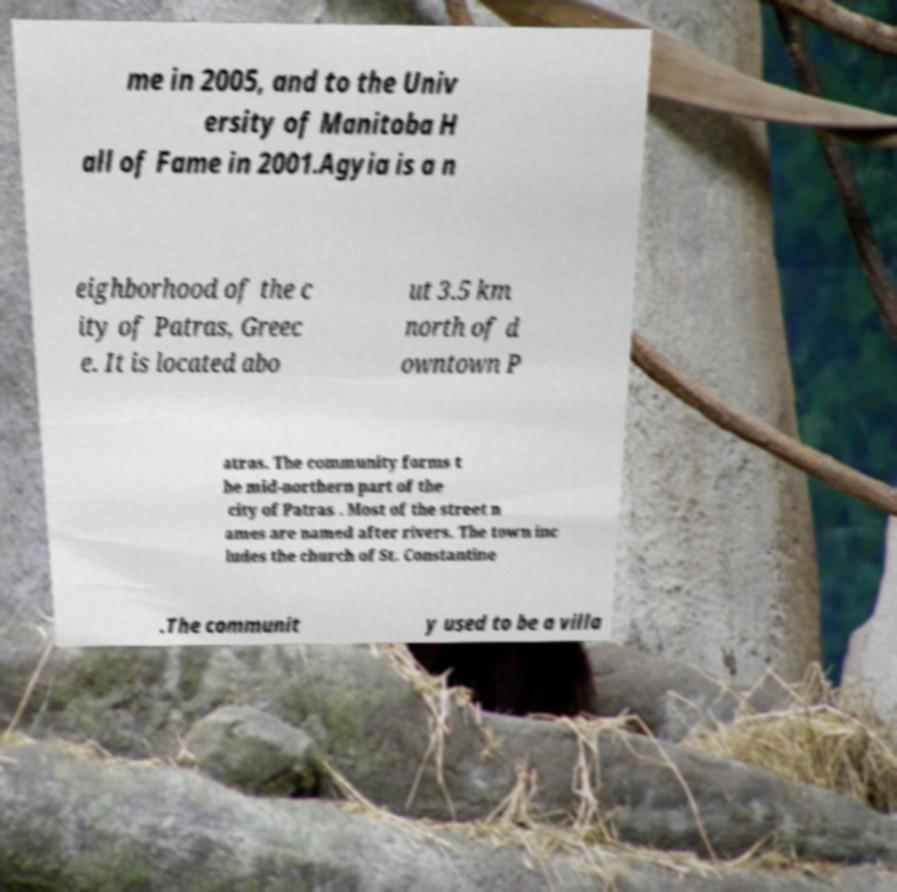Could you assist in decoding the text presented in this image and type it out clearly? me in 2005, and to the Univ ersity of Manitoba H all of Fame in 2001.Agyia is a n eighborhood of the c ity of Patras, Greec e. It is located abo ut 3.5 km north of d owntown P atras. The community forms t he mid-northern part of the city of Patras . Most of the street n ames are named after rivers. The town inc ludes the church of St. Constantine .The communit y used to be a villa 